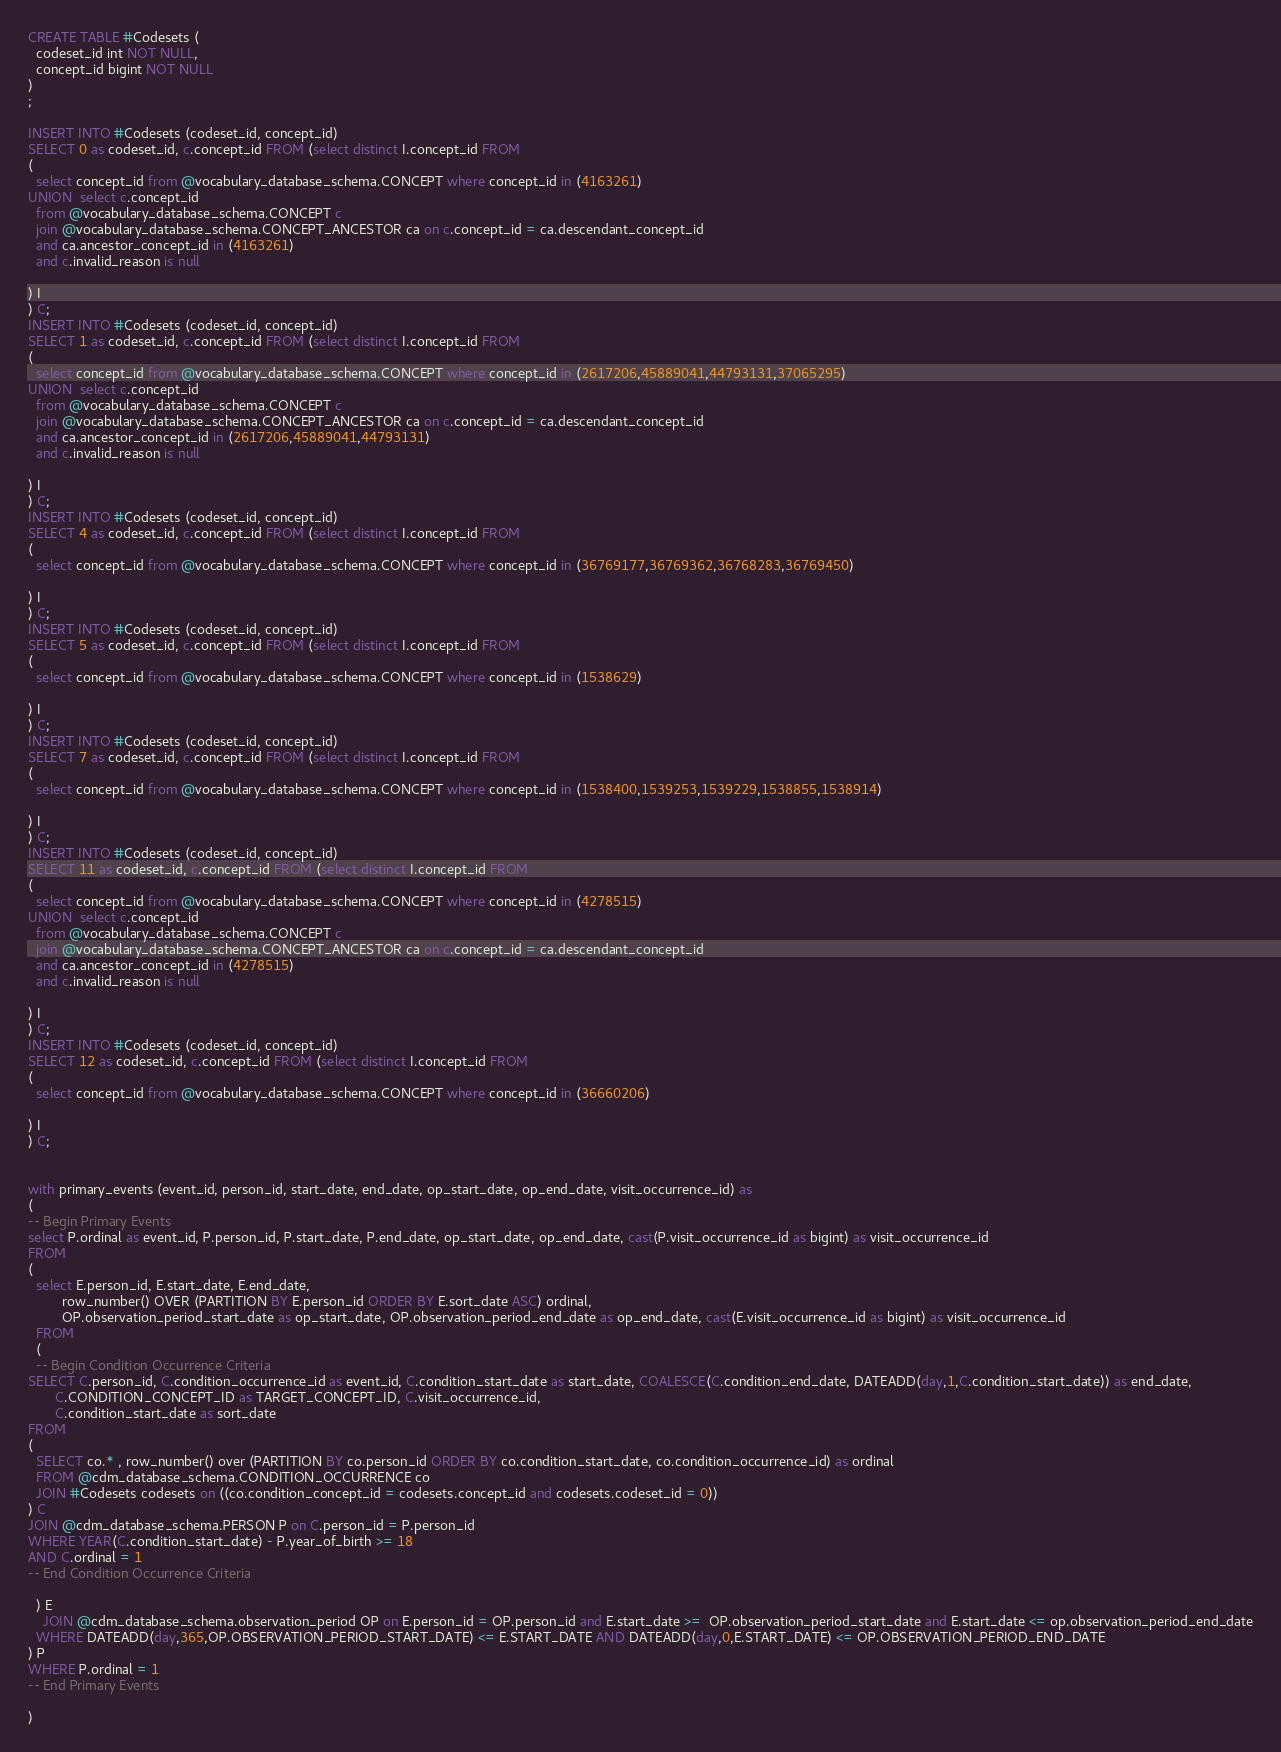Convert code to text. <code><loc_0><loc_0><loc_500><loc_500><_SQL_>CREATE TABLE #Codesets (
  codeset_id int NOT NULL,
  concept_id bigint NOT NULL
)
;

INSERT INTO #Codesets (codeset_id, concept_id)
SELECT 0 as codeset_id, c.concept_id FROM (select distinct I.concept_id FROM
( 
  select concept_id from @vocabulary_database_schema.CONCEPT where concept_id in (4163261)
UNION  select c.concept_id
  from @vocabulary_database_schema.CONCEPT c
  join @vocabulary_database_schema.CONCEPT_ANCESTOR ca on c.concept_id = ca.descendant_concept_id
  and ca.ancestor_concept_id in (4163261)
  and c.invalid_reason is null

) I
) C;
INSERT INTO #Codesets (codeset_id, concept_id)
SELECT 1 as codeset_id, c.concept_id FROM (select distinct I.concept_id FROM
( 
  select concept_id from @vocabulary_database_schema.CONCEPT where concept_id in (2617206,45889041,44793131,37065295)
UNION  select c.concept_id
  from @vocabulary_database_schema.CONCEPT c
  join @vocabulary_database_schema.CONCEPT_ANCESTOR ca on c.concept_id = ca.descendant_concept_id
  and ca.ancestor_concept_id in (2617206,45889041,44793131)
  and c.invalid_reason is null

) I
) C;
INSERT INTO #Codesets (codeset_id, concept_id)
SELECT 4 as codeset_id, c.concept_id FROM (select distinct I.concept_id FROM
( 
  select concept_id from @vocabulary_database_schema.CONCEPT where concept_id in (36769177,36769362,36768283,36769450)

) I
) C;
INSERT INTO #Codesets (codeset_id, concept_id)
SELECT 5 as codeset_id, c.concept_id FROM (select distinct I.concept_id FROM
( 
  select concept_id from @vocabulary_database_schema.CONCEPT where concept_id in (1538629)

) I
) C;
INSERT INTO #Codesets (codeset_id, concept_id)
SELECT 7 as codeset_id, c.concept_id FROM (select distinct I.concept_id FROM
( 
  select concept_id from @vocabulary_database_schema.CONCEPT where concept_id in (1538400,1539253,1539229,1538855,1538914)

) I
) C;
INSERT INTO #Codesets (codeset_id, concept_id)
SELECT 11 as codeset_id, c.concept_id FROM (select distinct I.concept_id FROM
( 
  select concept_id from @vocabulary_database_schema.CONCEPT where concept_id in (4278515)
UNION  select c.concept_id
  from @vocabulary_database_schema.CONCEPT c
  join @vocabulary_database_schema.CONCEPT_ANCESTOR ca on c.concept_id = ca.descendant_concept_id
  and ca.ancestor_concept_id in (4278515)
  and c.invalid_reason is null

) I
) C;
INSERT INTO #Codesets (codeset_id, concept_id)
SELECT 12 as codeset_id, c.concept_id FROM (select distinct I.concept_id FROM
( 
  select concept_id from @vocabulary_database_schema.CONCEPT where concept_id in (36660206)

) I
) C;


with primary_events (event_id, person_id, start_date, end_date, op_start_date, op_end_date, visit_occurrence_id) as
(
-- Begin Primary Events
select P.ordinal as event_id, P.person_id, P.start_date, P.end_date, op_start_date, op_end_date, cast(P.visit_occurrence_id as bigint) as visit_occurrence_id
FROM
(
  select E.person_id, E.start_date, E.end_date,
         row_number() OVER (PARTITION BY E.person_id ORDER BY E.sort_date ASC) ordinal,
         OP.observation_period_start_date as op_start_date, OP.observation_period_end_date as op_end_date, cast(E.visit_occurrence_id as bigint) as visit_occurrence_id
  FROM 
  (
  -- Begin Condition Occurrence Criteria
SELECT C.person_id, C.condition_occurrence_id as event_id, C.condition_start_date as start_date, COALESCE(C.condition_end_date, DATEADD(day,1,C.condition_start_date)) as end_date,
       C.CONDITION_CONCEPT_ID as TARGET_CONCEPT_ID, C.visit_occurrence_id,
       C.condition_start_date as sort_date
FROM 
(
  SELECT co.* , row_number() over (PARTITION BY co.person_id ORDER BY co.condition_start_date, co.condition_occurrence_id) as ordinal
  FROM @cdm_database_schema.CONDITION_OCCURRENCE co
  JOIN #Codesets codesets on ((co.condition_concept_id = codesets.concept_id and codesets.codeset_id = 0))
) C
JOIN @cdm_database_schema.PERSON P on C.person_id = P.person_id
WHERE YEAR(C.condition_start_date) - P.year_of_birth >= 18
AND C.ordinal = 1
-- End Condition Occurrence Criteria

  ) E
	JOIN @cdm_database_schema.observation_period OP on E.person_id = OP.person_id and E.start_date >=  OP.observation_period_start_date and E.start_date <= op.observation_period_end_date
  WHERE DATEADD(day,365,OP.OBSERVATION_PERIOD_START_DATE) <= E.START_DATE AND DATEADD(day,0,E.START_DATE) <= OP.OBSERVATION_PERIOD_END_DATE
) P
WHERE P.ordinal = 1
-- End Primary Events

)</code> 